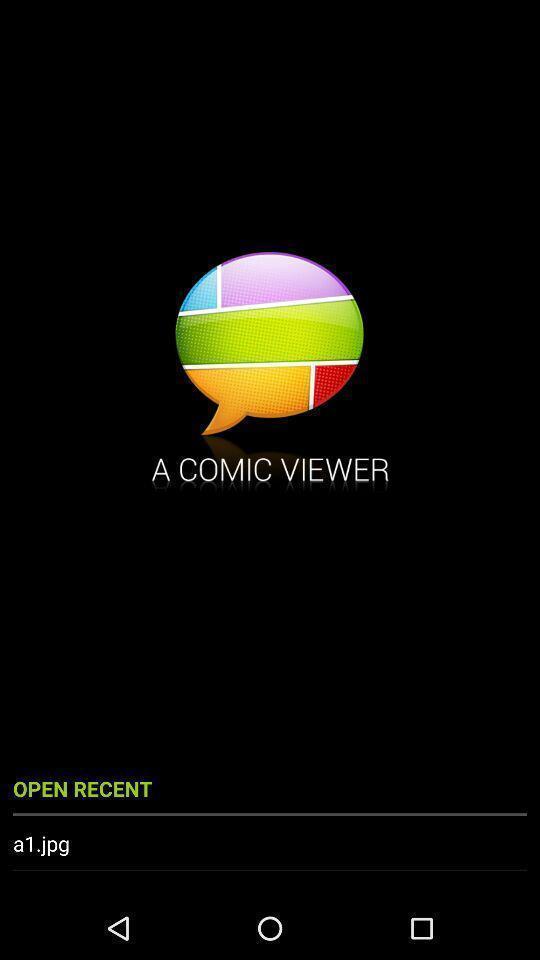Explain the elements present in this screenshot. Welcome page displayed. 